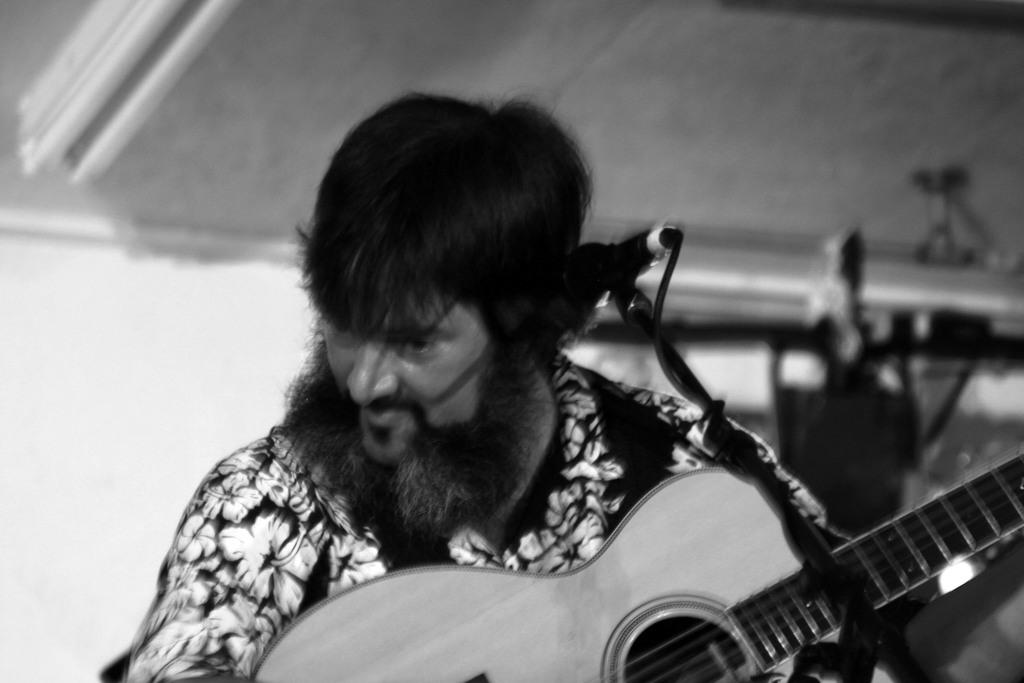Who is the main subject in the image? There is a man in the image. What is the man doing in the image? The man is playing a guitar. What object is in front of the man? There is a microphone in front of the man. What type of desk can be seen in the image? There is no desk present in the image. How many pieces of lumber are visible in the image? There is no lumber present in the image. 